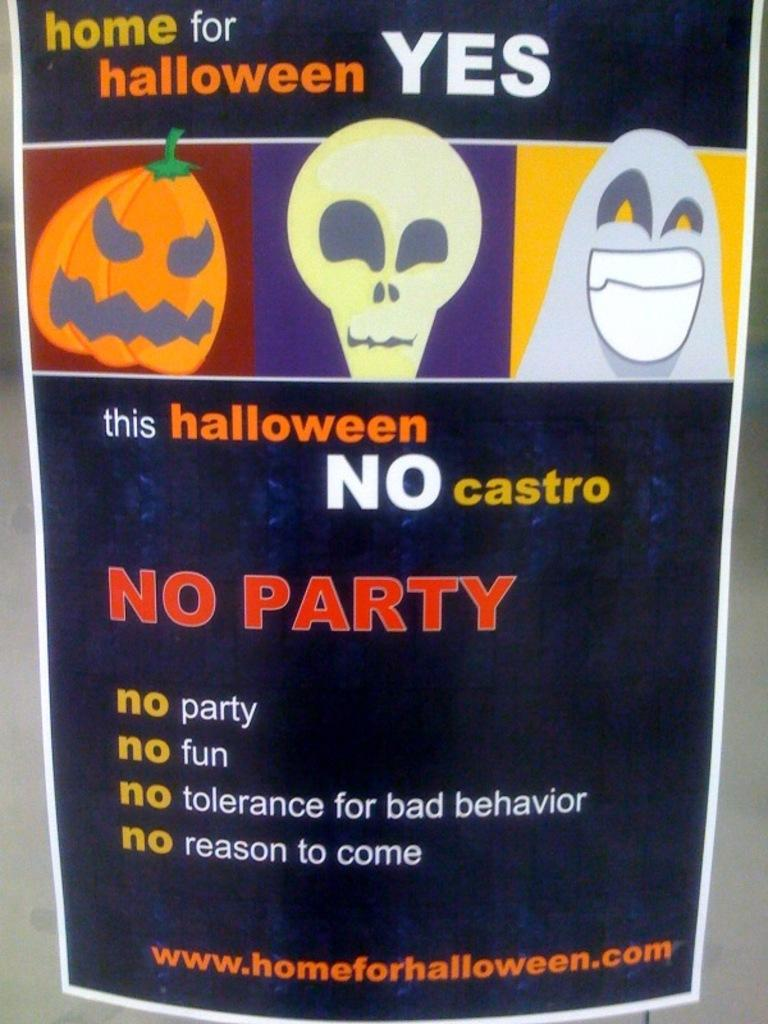What is present in the image that features a design or message? There is a poster in the image. What is the color of the poster? The poster is dark blue in color. What can be found on the poster besides its background color? The poster contains pictures and text. Where is the stove located in the image? There is no stove present in the image; it only features a poster. What type of thread is used to create the text on the poster? The poster is a flat, printed image, so there is no thread used to create the text. 